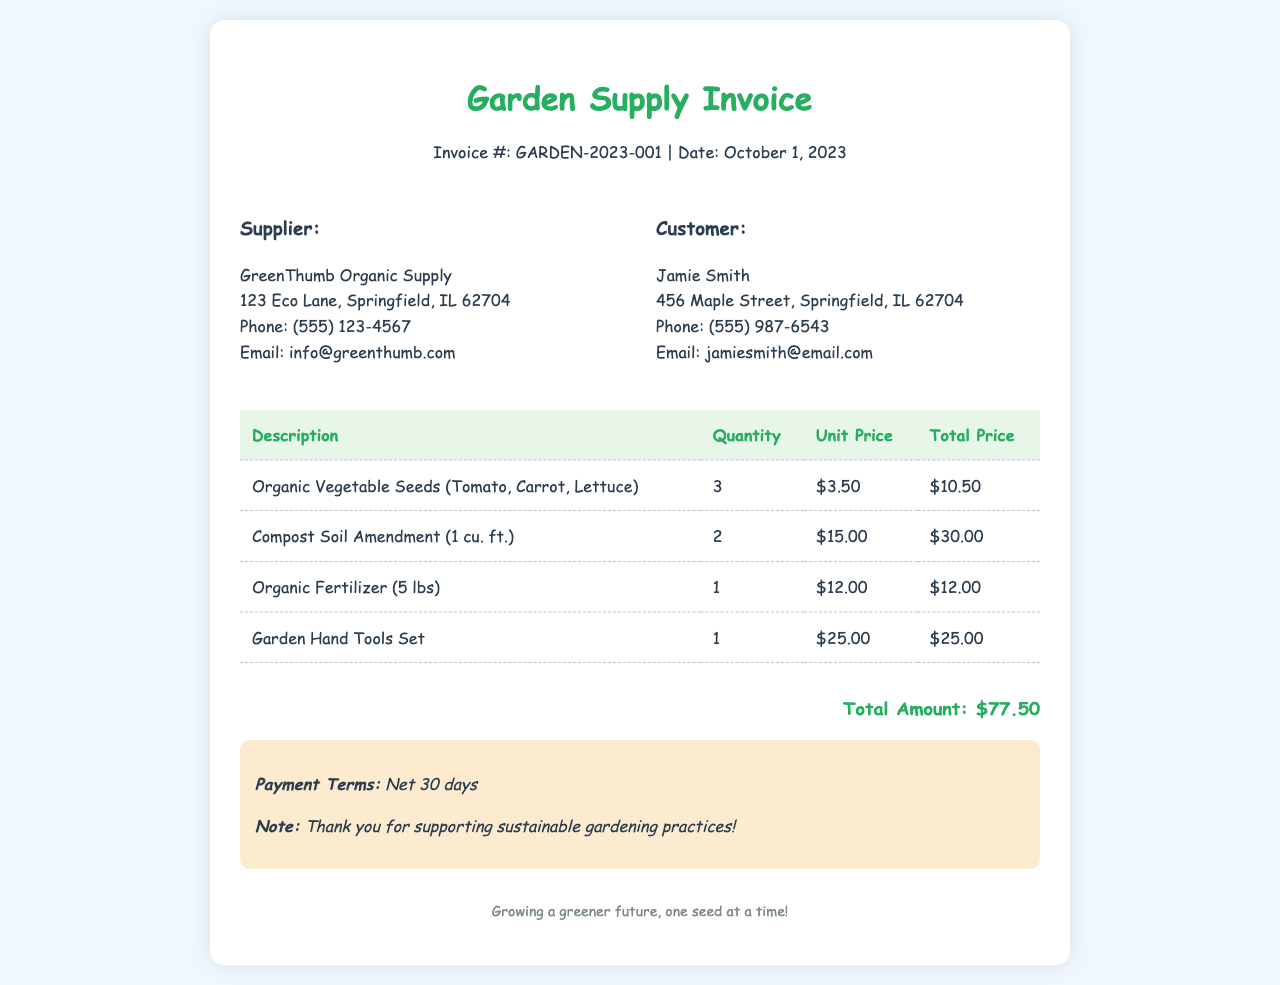What is the invoice number? The invoice number is specified in the header of the document as GARDEN-2023-001.
Answer: GARDEN-2023-001 What is the date of the invoice? The date of the invoice is stated in the header section, which is October 1, 2023.
Answer: October 1, 2023 Who is the supplier? The supplier's name is mentioned in the supplier details section as GreenThumb Organic Supply.
Answer: GreenThumb Organic Supply What is the total amount due? The total amount due is highlighted at the bottom of the invoice as $77.50.
Answer: $77.50 How many units of organic vegetable seeds were purchased? The quantity of organic vegetable seeds is listed in the invoice as 3.
Answer: 3 What is the unit price of the garden hand tools set? The unit price for the garden hand tools set is stated in the table as $25.00.
Answer: $25.00 What type of payment terms are specified? The payment terms mentioned in the notes section are Net 30 days.
Answer: Net 30 days Which city is the supplier located in? The supplier’s location includes the city Springfield, as seen in the address.
Answer: Springfield How many different types of items are listed in the invoice? The invoice lists a total of 4 different types of items in the table.
Answer: 4 